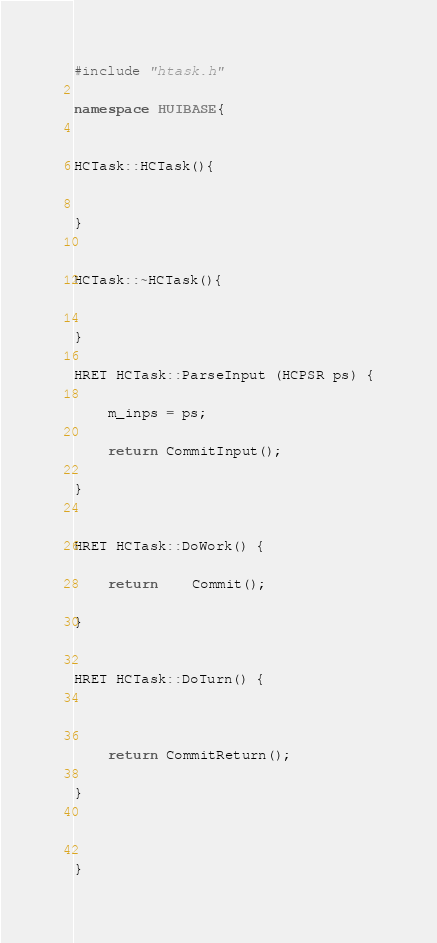Convert code to text. <code><loc_0><loc_0><loc_500><loc_500><_C++_>


#include "htask.h"

namespace HUIBASE{


HCTask::HCTask(){


}


HCTask::~HCTask(){


}

HRET HCTask::ParseInput (HCPSR ps) {

	m_inps = ps;

	return CommitInput();

}


HRET HCTask::DoWork() {

    return	Commit();

}


HRET HCTask::DoTurn() { 

    

    return CommitReturn();
    
}



}

</code> 